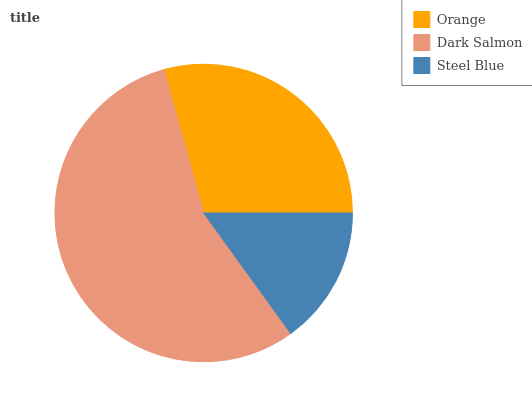Is Steel Blue the minimum?
Answer yes or no. Yes. Is Dark Salmon the maximum?
Answer yes or no. Yes. Is Dark Salmon the minimum?
Answer yes or no. No. Is Steel Blue the maximum?
Answer yes or no. No. Is Dark Salmon greater than Steel Blue?
Answer yes or no. Yes. Is Steel Blue less than Dark Salmon?
Answer yes or no. Yes. Is Steel Blue greater than Dark Salmon?
Answer yes or no. No. Is Dark Salmon less than Steel Blue?
Answer yes or no. No. Is Orange the high median?
Answer yes or no. Yes. Is Orange the low median?
Answer yes or no. Yes. Is Steel Blue the high median?
Answer yes or no. No. Is Steel Blue the low median?
Answer yes or no. No. 